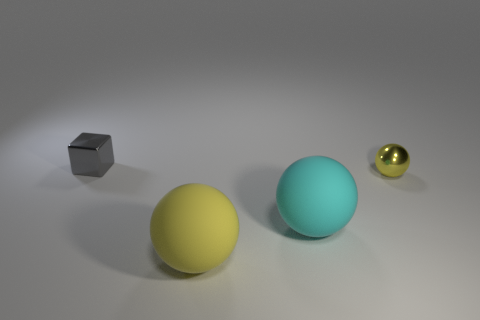Can you describe the lighting in the scene? The lighting in the image appears to be soft and diffused, coming from the upper left, which casts gentle shadows directly to the right of the objects, giving the scene a calm and balanced ambiance. 